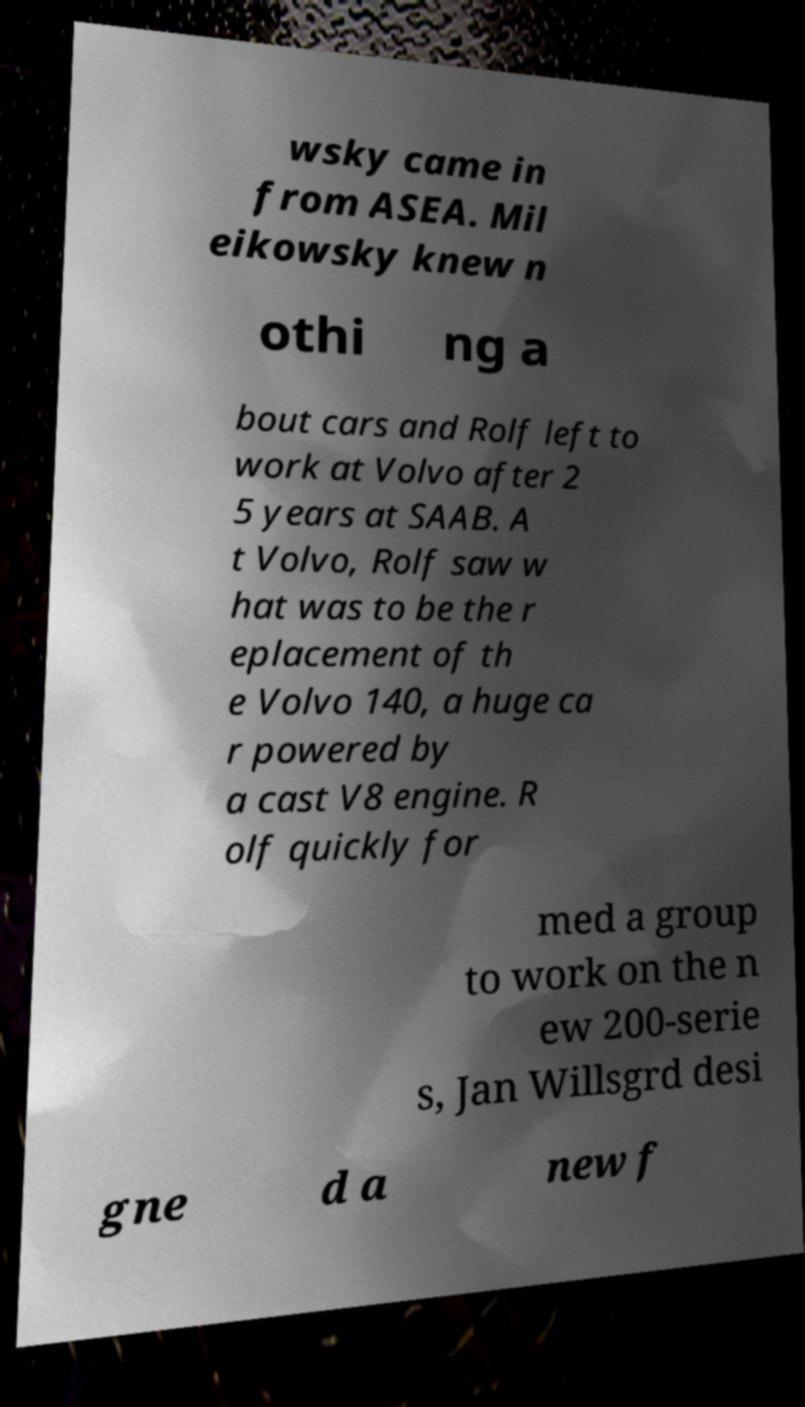Can you accurately transcribe the text from the provided image for me? wsky came in from ASEA. Mil eikowsky knew n othi ng a bout cars and Rolf left to work at Volvo after 2 5 years at SAAB. A t Volvo, Rolf saw w hat was to be the r eplacement of th e Volvo 140, a huge ca r powered by a cast V8 engine. R olf quickly for med a group to work on the n ew 200-serie s, Jan Willsgrd desi gne d a new f 